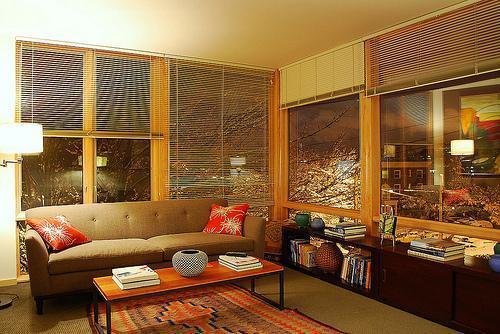How many coffee tables in the room?
Give a very brief answer. 1. How many pillows are on the sofa?
Give a very brief answer. 2. 